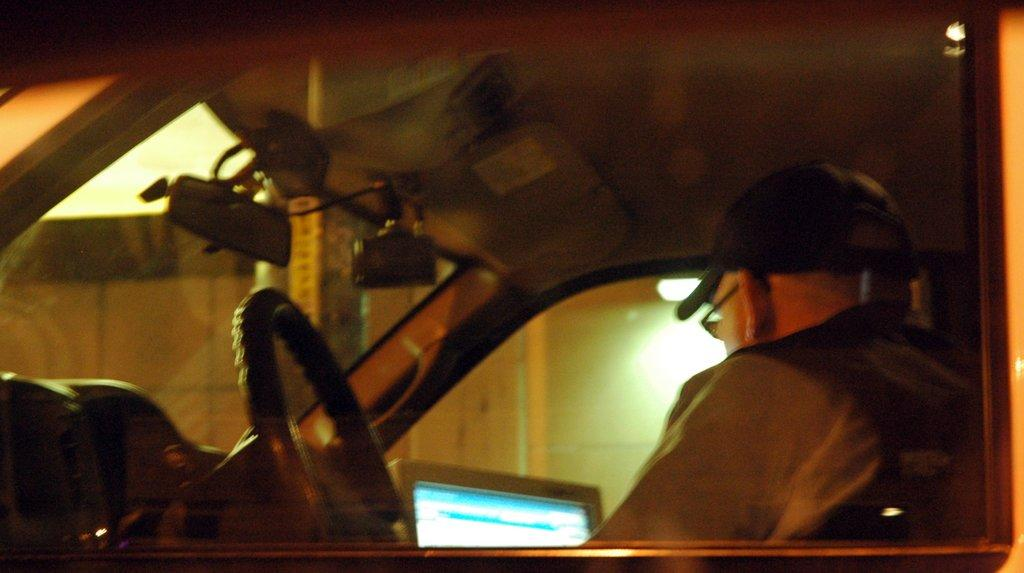Who is present in the image? There is a man in the image. What is the man wearing on his head? The man is wearing a hat. What type of eyewear is the man wearing? The man is wearing spectacles. Where is the man located in the image? The man is sitting in a vehicle. What electronic device can be seen in the image? There is a laptop in the image. What type of structures are visible in the background of the image? There are buildings visible in the image. How many boys are playing with the toad in the image? There are no boys or toads present in the image. 